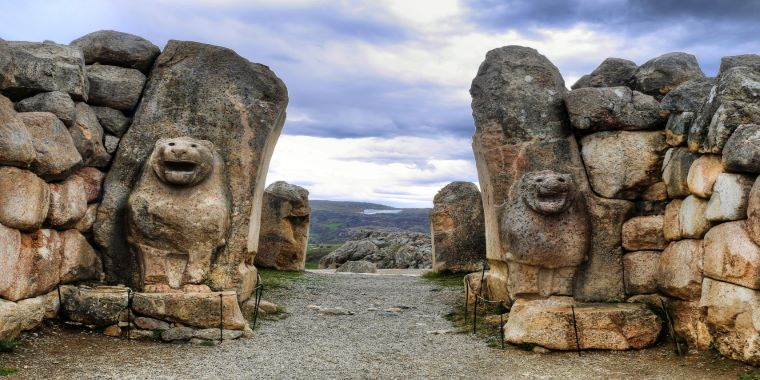Describe the significance of the lions in the gate and what they symbolize. The lion sculptures at the Lion Gate in Hattusa symbolize power, protection, and the divine. In ancient Hittite culture, lions were often associated with royalty and divine protection, indicating that this gateway was not just an entry point but a passage to a sacred or significant area. The vigilant stance of the lions represents a protective barrier, warding off evil and safeguarding the inhabitants. These sculptures underscore the importance of the gate within the city's socio-religious context, marking it as a monumental and revered entryway. 